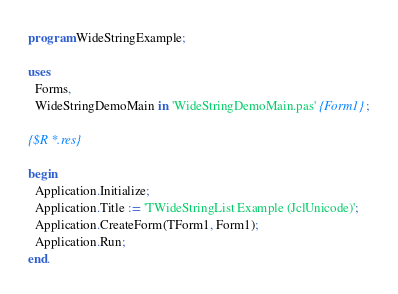<code> <loc_0><loc_0><loc_500><loc_500><_Pascal_>program WideStringExample;

uses
  Forms,
  WideStringDemoMain in 'WideStringDemoMain.pas' {Form1};

{$R *.res}

begin
  Application.Initialize;
  Application.Title := 'TWideStringList Example (JclUnicode)';
  Application.CreateForm(TForm1, Form1);
  Application.Run;
end.
</code> 